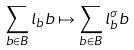Convert formula to latex. <formula><loc_0><loc_0><loc_500><loc_500>\sum _ { b \in B } l _ { b } b \mapsto \sum _ { b \in B } l _ { b } ^ { \sigma } b</formula> 